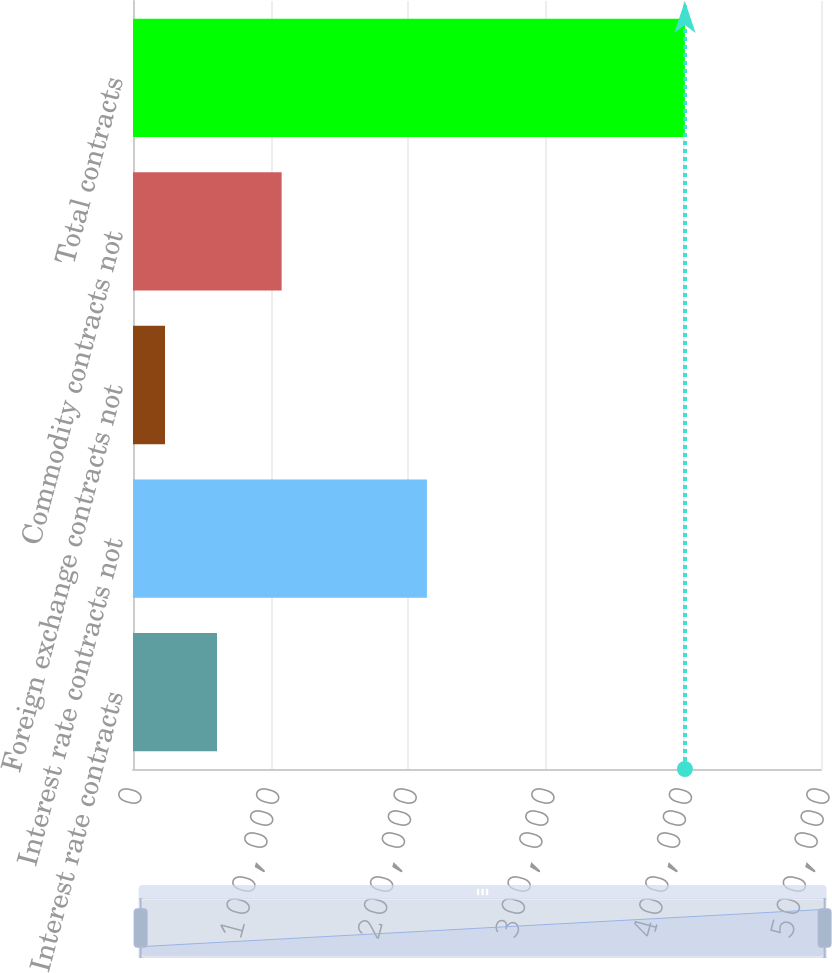Convert chart to OTSL. <chart><loc_0><loc_0><loc_500><loc_500><bar_chart><fcel>Interest rate contracts<fcel>Interest rate contracts not<fcel>Foreign exchange contracts not<fcel>Commodity contracts not<fcel>Total contracts<nl><fcel>61047.8<fcel>213587<fcel>23265<fcel>108026<fcel>401093<nl></chart> 